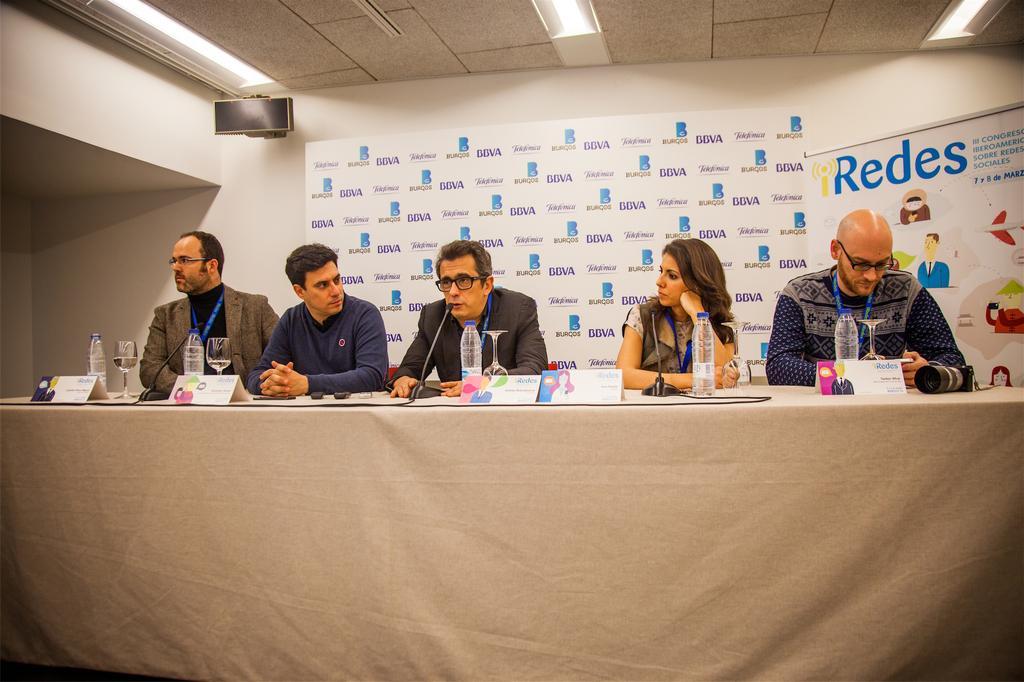Describe this image in one or two sentences. In this image we can see a few people sitting on the chairs, in front of them, we can see a table covered with the cloth, on the table, we can see some water bottles, glasses, mics and some other objects, there are some posters with some text and images, at the top of the roof we can see some lights. 